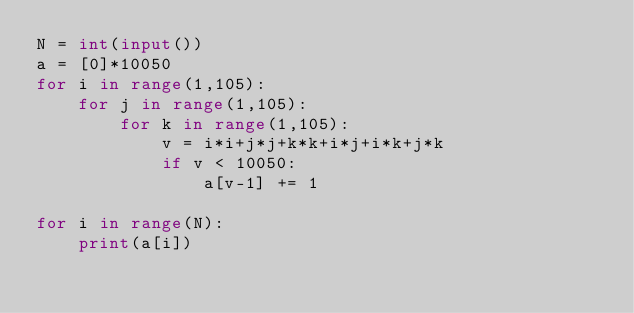<code> <loc_0><loc_0><loc_500><loc_500><_Python_>N = int(input())
a = [0]*10050
for i in range(1,105):
    for j in range(1,105):
        for k in range(1,105):
            v = i*i+j*j+k*k+i*j+i*k+j*k
            if v < 10050:
                a[v-1] += 1

for i in range(N):
    print(a[i])
</code> 